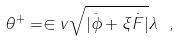<formula> <loc_0><loc_0><loc_500><loc_500>\theta ^ { + } = \in v { \sqrt { | \dot { \phi } + \xi \dot { F } | } } \lambda \ ,</formula> 